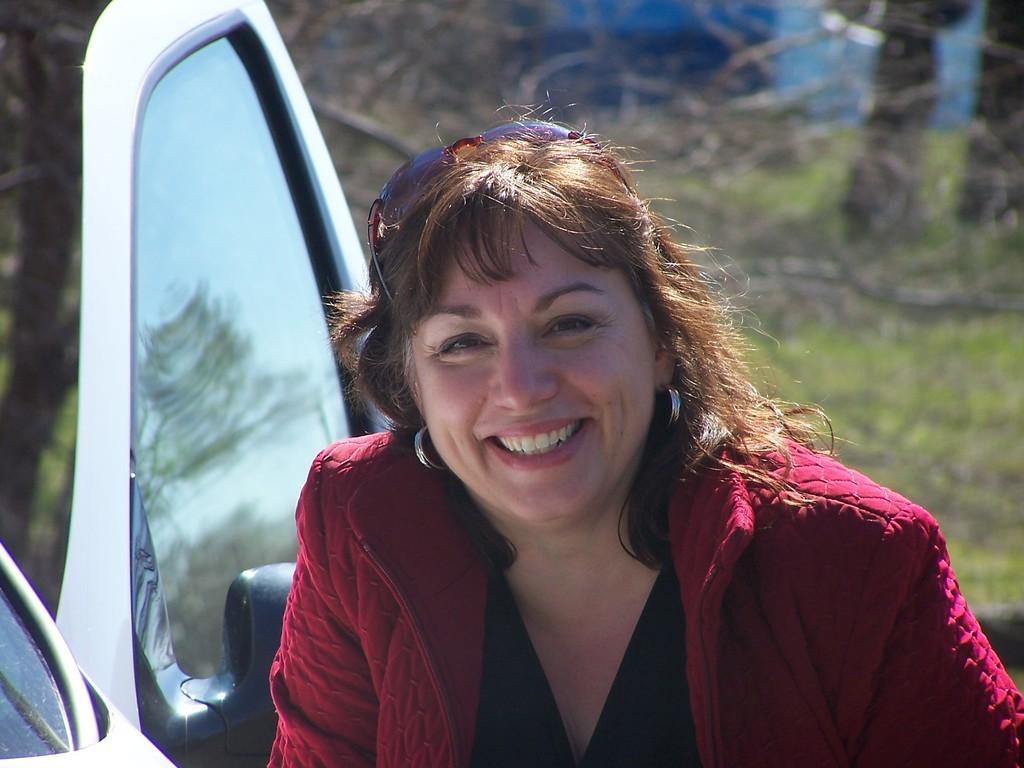Could you give a brief overview of what you see in this image? In this image I can see a person and the person is wearing red and black color dress. Background I can see a vehicle, and trees in green color. 